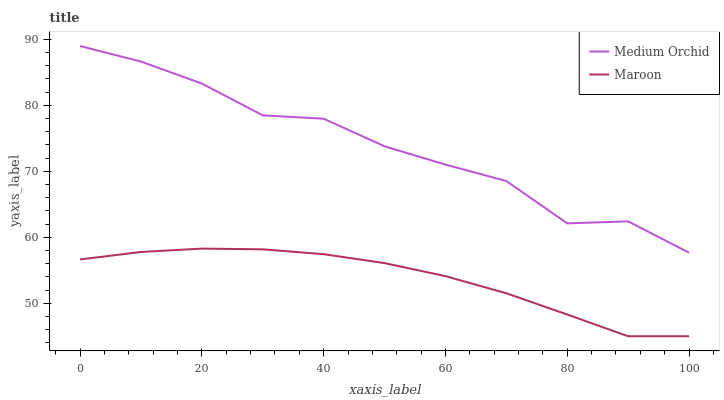Does Maroon have the minimum area under the curve?
Answer yes or no. Yes. Does Medium Orchid have the maximum area under the curve?
Answer yes or no. Yes. Does Maroon have the maximum area under the curve?
Answer yes or no. No. Is Maroon the smoothest?
Answer yes or no. Yes. Is Medium Orchid the roughest?
Answer yes or no. Yes. Is Maroon the roughest?
Answer yes or no. No. Does Medium Orchid have the highest value?
Answer yes or no. Yes. Does Maroon have the highest value?
Answer yes or no. No. Is Maroon less than Medium Orchid?
Answer yes or no. Yes. Is Medium Orchid greater than Maroon?
Answer yes or no. Yes. Does Maroon intersect Medium Orchid?
Answer yes or no. No. 